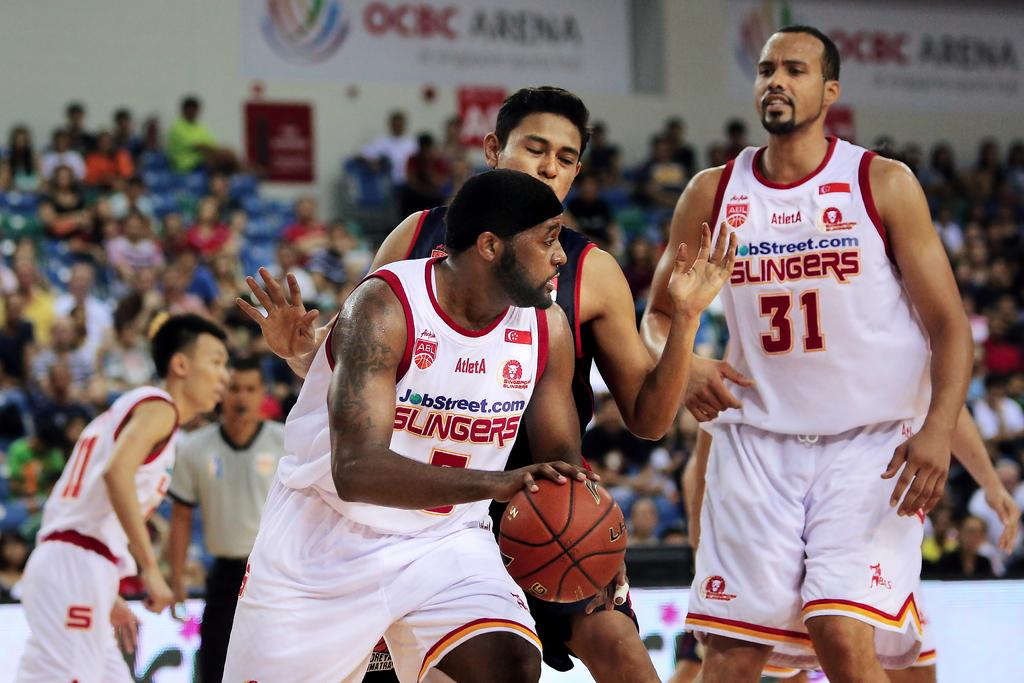<image>
Create a compact narrative representing the image presented. A Slingers player has possession of the basketball at an indoor stadium. 